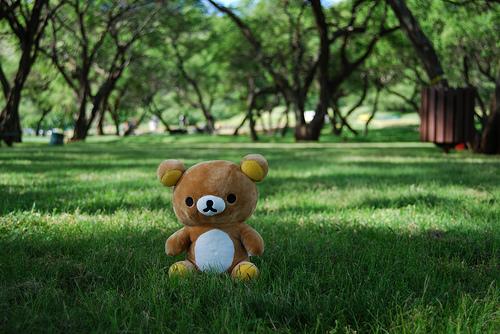Is the bear alive?
Short answer required. No. Is this a happy teddy bear?
Answer briefly. No. What color is the trash can?
Short answer required. Brown. What kind of toy is this?
Short answer required. Teddy bear. 